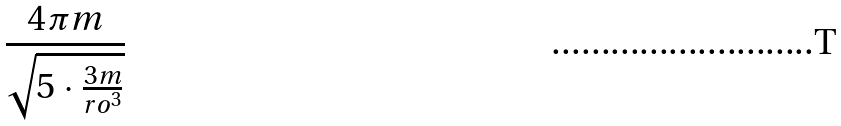Convert formula to latex. <formula><loc_0><loc_0><loc_500><loc_500>\frac { 4 \pi m } { \sqrt { 5 \cdot \frac { 3 m } { r o ^ { 3 } } } }</formula> 